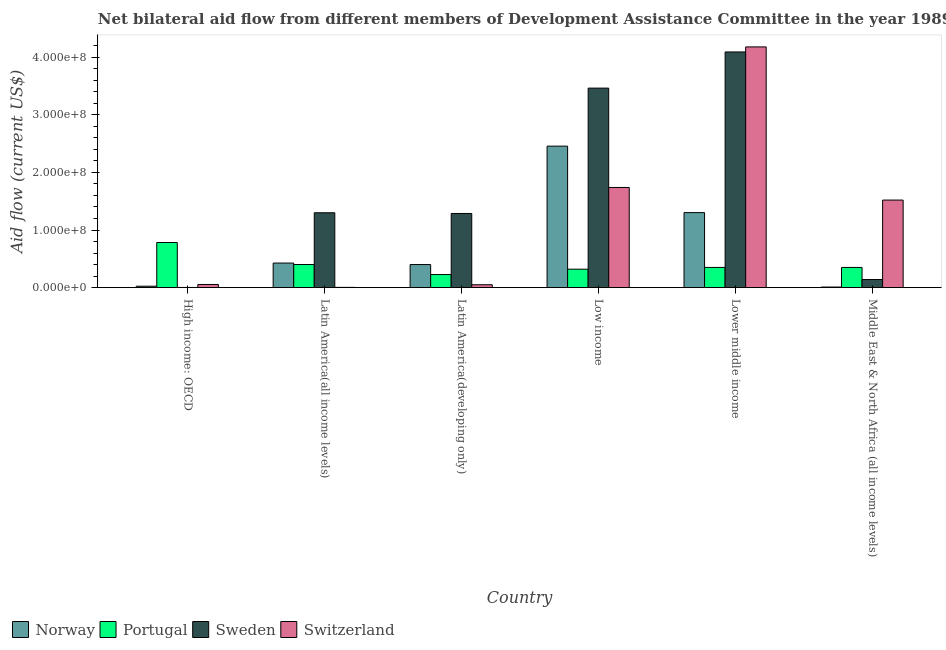How many different coloured bars are there?
Your response must be concise. 4. Are the number of bars on each tick of the X-axis equal?
Make the answer very short. Yes. How many bars are there on the 5th tick from the left?
Give a very brief answer. 4. What is the label of the 2nd group of bars from the left?
Provide a succinct answer. Latin America(all income levels). What is the amount of aid given by norway in Latin America(developing only)?
Ensure brevity in your answer.  4.01e+07. Across all countries, what is the maximum amount of aid given by portugal?
Your response must be concise. 7.84e+07. Across all countries, what is the minimum amount of aid given by switzerland?
Offer a terse response. 4.80e+05. In which country was the amount of aid given by switzerland maximum?
Your response must be concise. Lower middle income. In which country was the amount of aid given by portugal minimum?
Provide a short and direct response. Latin America(developing only). What is the total amount of aid given by portugal in the graph?
Your answer should be very brief. 2.44e+08. What is the difference between the amount of aid given by norway in High income: OECD and that in Latin America(developing only)?
Offer a terse response. -3.76e+07. What is the difference between the amount of aid given by switzerland in Latin America(developing only) and the amount of aid given by portugal in Middle East & North Africa (all income levels)?
Your answer should be compact. -3.00e+07. What is the average amount of aid given by switzerland per country?
Provide a short and direct response. 1.26e+08. What is the difference between the amount of aid given by sweden and amount of aid given by norway in Latin America(all income levels)?
Give a very brief answer. 8.72e+07. In how many countries, is the amount of aid given by portugal greater than 180000000 US$?
Your answer should be very brief. 0. What is the ratio of the amount of aid given by sweden in High income: OECD to that in Latin America(all income levels)?
Your answer should be compact. 0. Is the difference between the amount of aid given by portugal in Latin America(all income levels) and Middle East & North Africa (all income levels) greater than the difference between the amount of aid given by norway in Latin America(all income levels) and Middle East & North Africa (all income levels)?
Your answer should be very brief. No. What is the difference between the highest and the second highest amount of aid given by switzerland?
Provide a short and direct response. 2.44e+08. What is the difference between the highest and the lowest amount of aid given by switzerland?
Your answer should be compact. 4.17e+08. In how many countries, is the amount of aid given by switzerland greater than the average amount of aid given by switzerland taken over all countries?
Your answer should be compact. 3. Is it the case that in every country, the sum of the amount of aid given by portugal and amount of aid given by sweden is greater than the sum of amount of aid given by norway and amount of aid given by switzerland?
Keep it short and to the point. Yes. What does the 4th bar from the left in Low income represents?
Provide a short and direct response. Switzerland. What does the 1st bar from the right in Middle East & North Africa (all income levels) represents?
Your answer should be compact. Switzerland. Is it the case that in every country, the sum of the amount of aid given by norway and amount of aid given by portugal is greater than the amount of aid given by sweden?
Your answer should be compact. No. How many bars are there?
Your answer should be very brief. 24. Are the values on the major ticks of Y-axis written in scientific E-notation?
Ensure brevity in your answer.  Yes. Does the graph contain any zero values?
Offer a very short reply. No. Does the graph contain grids?
Keep it short and to the point. No. How many legend labels are there?
Make the answer very short. 4. How are the legend labels stacked?
Your answer should be compact. Horizontal. What is the title of the graph?
Offer a very short reply. Net bilateral aid flow from different members of Development Assistance Committee in the year 1989. Does "Portugal" appear as one of the legend labels in the graph?
Provide a short and direct response. Yes. What is the label or title of the X-axis?
Your answer should be very brief. Country. What is the Aid flow (current US$) of Norway in High income: OECD?
Your response must be concise. 2.52e+06. What is the Aid flow (current US$) of Portugal in High income: OECD?
Provide a succinct answer. 7.84e+07. What is the Aid flow (current US$) of Switzerland in High income: OECD?
Offer a terse response. 5.54e+06. What is the Aid flow (current US$) in Norway in Latin America(all income levels)?
Provide a short and direct response. 4.27e+07. What is the Aid flow (current US$) of Portugal in Latin America(all income levels)?
Offer a very short reply. 4.01e+07. What is the Aid flow (current US$) in Sweden in Latin America(all income levels)?
Your answer should be compact. 1.30e+08. What is the Aid flow (current US$) of Switzerland in Latin America(all income levels)?
Offer a terse response. 4.80e+05. What is the Aid flow (current US$) in Norway in Latin America(developing only)?
Provide a short and direct response. 4.01e+07. What is the Aid flow (current US$) in Portugal in Latin America(developing only)?
Your response must be concise. 2.28e+07. What is the Aid flow (current US$) of Sweden in Latin America(developing only)?
Your response must be concise. 1.29e+08. What is the Aid flow (current US$) in Switzerland in Latin America(developing only)?
Offer a terse response. 5.06e+06. What is the Aid flow (current US$) in Norway in Low income?
Your response must be concise. 2.45e+08. What is the Aid flow (current US$) in Portugal in Low income?
Your answer should be very brief. 3.21e+07. What is the Aid flow (current US$) of Sweden in Low income?
Give a very brief answer. 3.46e+08. What is the Aid flow (current US$) of Switzerland in Low income?
Keep it short and to the point. 1.74e+08. What is the Aid flow (current US$) of Norway in Lower middle income?
Your answer should be compact. 1.30e+08. What is the Aid flow (current US$) in Portugal in Lower middle income?
Provide a short and direct response. 3.51e+07. What is the Aid flow (current US$) in Sweden in Lower middle income?
Your response must be concise. 4.09e+08. What is the Aid flow (current US$) of Switzerland in Lower middle income?
Offer a very short reply. 4.18e+08. What is the Aid flow (current US$) in Norway in Middle East & North Africa (all income levels)?
Give a very brief answer. 1.06e+06. What is the Aid flow (current US$) of Portugal in Middle East & North Africa (all income levels)?
Provide a succinct answer. 3.51e+07. What is the Aid flow (current US$) in Sweden in Middle East & North Africa (all income levels)?
Ensure brevity in your answer.  1.41e+07. What is the Aid flow (current US$) of Switzerland in Middle East & North Africa (all income levels)?
Make the answer very short. 1.52e+08. Across all countries, what is the maximum Aid flow (current US$) of Norway?
Your response must be concise. 2.45e+08. Across all countries, what is the maximum Aid flow (current US$) in Portugal?
Provide a short and direct response. 7.84e+07. Across all countries, what is the maximum Aid flow (current US$) of Sweden?
Provide a succinct answer. 4.09e+08. Across all countries, what is the maximum Aid flow (current US$) of Switzerland?
Keep it short and to the point. 4.18e+08. Across all countries, what is the minimum Aid flow (current US$) in Norway?
Offer a very short reply. 1.06e+06. Across all countries, what is the minimum Aid flow (current US$) of Portugal?
Ensure brevity in your answer.  2.28e+07. Across all countries, what is the minimum Aid flow (current US$) in Sweden?
Offer a terse response. 3.60e+05. What is the total Aid flow (current US$) in Norway in the graph?
Your response must be concise. 4.62e+08. What is the total Aid flow (current US$) in Portugal in the graph?
Provide a succinct answer. 2.44e+08. What is the total Aid flow (current US$) in Sweden in the graph?
Keep it short and to the point. 1.03e+09. What is the total Aid flow (current US$) of Switzerland in the graph?
Keep it short and to the point. 7.54e+08. What is the difference between the Aid flow (current US$) in Norway in High income: OECD and that in Latin America(all income levels)?
Keep it short and to the point. -4.02e+07. What is the difference between the Aid flow (current US$) of Portugal in High income: OECD and that in Latin America(all income levels)?
Offer a very short reply. 3.82e+07. What is the difference between the Aid flow (current US$) in Sweden in High income: OECD and that in Latin America(all income levels)?
Your response must be concise. -1.30e+08. What is the difference between the Aid flow (current US$) of Switzerland in High income: OECD and that in Latin America(all income levels)?
Provide a short and direct response. 5.06e+06. What is the difference between the Aid flow (current US$) of Norway in High income: OECD and that in Latin America(developing only)?
Keep it short and to the point. -3.76e+07. What is the difference between the Aid flow (current US$) of Portugal in High income: OECD and that in Latin America(developing only)?
Provide a succinct answer. 5.56e+07. What is the difference between the Aid flow (current US$) of Sweden in High income: OECD and that in Latin America(developing only)?
Offer a very short reply. -1.28e+08. What is the difference between the Aid flow (current US$) in Switzerland in High income: OECD and that in Latin America(developing only)?
Offer a very short reply. 4.80e+05. What is the difference between the Aid flow (current US$) in Norway in High income: OECD and that in Low income?
Provide a succinct answer. -2.43e+08. What is the difference between the Aid flow (current US$) in Portugal in High income: OECD and that in Low income?
Your answer should be compact. 4.63e+07. What is the difference between the Aid flow (current US$) in Sweden in High income: OECD and that in Low income?
Make the answer very short. -3.46e+08. What is the difference between the Aid flow (current US$) in Switzerland in High income: OECD and that in Low income?
Make the answer very short. -1.68e+08. What is the difference between the Aid flow (current US$) of Norway in High income: OECD and that in Lower middle income?
Offer a very short reply. -1.28e+08. What is the difference between the Aid flow (current US$) of Portugal in High income: OECD and that in Lower middle income?
Your response must be concise. 4.33e+07. What is the difference between the Aid flow (current US$) of Sweden in High income: OECD and that in Lower middle income?
Provide a succinct answer. -4.09e+08. What is the difference between the Aid flow (current US$) in Switzerland in High income: OECD and that in Lower middle income?
Your answer should be very brief. -4.12e+08. What is the difference between the Aid flow (current US$) in Norway in High income: OECD and that in Middle East & North Africa (all income levels)?
Offer a very short reply. 1.46e+06. What is the difference between the Aid flow (current US$) in Portugal in High income: OECD and that in Middle East & North Africa (all income levels)?
Ensure brevity in your answer.  4.33e+07. What is the difference between the Aid flow (current US$) in Sweden in High income: OECD and that in Middle East & North Africa (all income levels)?
Give a very brief answer. -1.37e+07. What is the difference between the Aid flow (current US$) in Switzerland in High income: OECD and that in Middle East & North Africa (all income levels)?
Your answer should be compact. -1.46e+08. What is the difference between the Aid flow (current US$) in Norway in Latin America(all income levels) and that in Latin America(developing only)?
Ensure brevity in your answer.  2.59e+06. What is the difference between the Aid flow (current US$) in Portugal in Latin America(all income levels) and that in Latin America(developing only)?
Your answer should be very brief. 1.74e+07. What is the difference between the Aid flow (current US$) in Sweden in Latin America(all income levels) and that in Latin America(developing only)?
Offer a terse response. 1.23e+06. What is the difference between the Aid flow (current US$) in Switzerland in Latin America(all income levels) and that in Latin America(developing only)?
Make the answer very short. -4.58e+06. What is the difference between the Aid flow (current US$) in Norway in Latin America(all income levels) and that in Low income?
Ensure brevity in your answer.  -2.03e+08. What is the difference between the Aid flow (current US$) in Portugal in Latin America(all income levels) and that in Low income?
Keep it short and to the point. 8.08e+06. What is the difference between the Aid flow (current US$) of Sweden in Latin America(all income levels) and that in Low income?
Your response must be concise. -2.16e+08. What is the difference between the Aid flow (current US$) of Switzerland in Latin America(all income levels) and that in Low income?
Offer a very short reply. -1.73e+08. What is the difference between the Aid flow (current US$) in Norway in Latin America(all income levels) and that in Lower middle income?
Offer a very short reply. -8.75e+07. What is the difference between the Aid flow (current US$) of Portugal in Latin America(all income levels) and that in Lower middle income?
Your answer should be very brief. 5.04e+06. What is the difference between the Aid flow (current US$) in Sweden in Latin America(all income levels) and that in Lower middle income?
Your answer should be compact. -2.79e+08. What is the difference between the Aid flow (current US$) in Switzerland in Latin America(all income levels) and that in Lower middle income?
Give a very brief answer. -4.17e+08. What is the difference between the Aid flow (current US$) in Norway in Latin America(all income levels) and that in Middle East & North Africa (all income levels)?
Make the answer very short. 4.16e+07. What is the difference between the Aid flow (current US$) of Portugal in Latin America(all income levels) and that in Middle East & North Africa (all income levels)?
Provide a succinct answer. 5.04e+06. What is the difference between the Aid flow (current US$) of Sweden in Latin America(all income levels) and that in Middle East & North Africa (all income levels)?
Provide a succinct answer. 1.16e+08. What is the difference between the Aid flow (current US$) of Switzerland in Latin America(all income levels) and that in Middle East & North Africa (all income levels)?
Give a very brief answer. -1.51e+08. What is the difference between the Aid flow (current US$) in Norway in Latin America(developing only) and that in Low income?
Give a very brief answer. -2.05e+08. What is the difference between the Aid flow (current US$) in Portugal in Latin America(developing only) and that in Low income?
Your answer should be compact. -9.30e+06. What is the difference between the Aid flow (current US$) in Sweden in Latin America(developing only) and that in Low income?
Provide a short and direct response. -2.17e+08. What is the difference between the Aid flow (current US$) in Switzerland in Latin America(developing only) and that in Low income?
Your answer should be very brief. -1.69e+08. What is the difference between the Aid flow (current US$) in Norway in Latin America(developing only) and that in Lower middle income?
Keep it short and to the point. -9.01e+07. What is the difference between the Aid flow (current US$) of Portugal in Latin America(developing only) and that in Lower middle income?
Your answer should be compact. -1.23e+07. What is the difference between the Aid flow (current US$) in Sweden in Latin America(developing only) and that in Lower middle income?
Your answer should be compact. -2.80e+08. What is the difference between the Aid flow (current US$) in Switzerland in Latin America(developing only) and that in Lower middle income?
Your answer should be compact. -4.13e+08. What is the difference between the Aid flow (current US$) in Norway in Latin America(developing only) and that in Middle East & North Africa (all income levels)?
Ensure brevity in your answer.  3.90e+07. What is the difference between the Aid flow (current US$) of Portugal in Latin America(developing only) and that in Middle East & North Africa (all income levels)?
Offer a terse response. -1.23e+07. What is the difference between the Aid flow (current US$) of Sweden in Latin America(developing only) and that in Middle East & North Africa (all income levels)?
Offer a very short reply. 1.15e+08. What is the difference between the Aid flow (current US$) in Switzerland in Latin America(developing only) and that in Middle East & North Africa (all income levels)?
Ensure brevity in your answer.  -1.47e+08. What is the difference between the Aid flow (current US$) of Norway in Low income and that in Lower middle income?
Ensure brevity in your answer.  1.15e+08. What is the difference between the Aid flow (current US$) of Portugal in Low income and that in Lower middle income?
Give a very brief answer. -3.04e+06. What is the difference between the Aid flow (current US$) in Sweden in Low income and that in Lower middle income?
Give a very brief answer. -6.27e+07. What is the difference between the Aid flow (current US$) in Switzerland in Low income and that in Lower middle income?
Your response must be concise. -2.44e+08. What is the difference between the Aid flow (current US$) of Norway in Low income and that in Middle East & North Africa (all income levels)?
Keep it short and to the point. 2.44e+08. What is the difference between the Aid flow (current US$) in Portugal in Low income and that in Middle East & North Africa (all income levels)?
Your answer should be very brief. -3.04e+06. What is the difference between the Aid flow (current US$) in Sweden in Low income and that in Middle East & North Africa (all income levels)?
Provide a succinct answer. 3.32e+08. What is the difference between the Aid flow (current US$) of Switzerland in Low income and that in Middle East & North Africa (all income levels)?
Your answer should be compact. 2.18e+07. What is the difference between the Aid flow (current US$) in Norway in Lower middle income and that in Middle East & North Africa (all income levels)?
Offer a very short reply. 1.29e+08. What is the difference between the Aid flow (current US$) of Portugal in Lower middle income and that in Middle East & North Africa (all income levels)?
Make the answer very short. 0. What is the difference between the Aid flow (current US$) of Sweden in Lower middle income and that in Middle East & North Africa (all income levels)?
Make the answer very short. 3.95e+08. What is the difference between the Aid flow (current US$) in Switzerland in Lower middle income and that in Middle East & North Africa (all income levels)?
Offer a very short reply. 2.66e+08. What is the difference between the Aid flow (current US$) in Norway in High income: OECD and the Aid flow (current US$) in Portugal in Latin America(all income levels)?
Offer a terse response. -3.76e+07. What is the difference between the Aid flow (current US$) of Norway in High income: OECD and the Aid flow (current US$) of Sweden in Latin America(all income levels)?
Provide a succinct answer. -1.27e+08. What is the difference between the Aid flow (current US$) of Norway in High income: OECD and the Aid flow (current US$) of Switzerland in Latin America(all income levels)?
Keep it short and to the point. 2.04e+06. What is the difference between the Aid flow (current US$) of Portugal in High income: OECD and the Aid flow (current US$) of Sweden in Latin America(all income levels)?
Offer a very short reply. -5.16e+07. What is the difference between the Aid flow (current US$) in Portugal in High income: OECD and the Aid flow (current US$) in Switzerland in Latin America(all income levels)?
Give a very brief answer. 7.79e+07. What is the difference between the Aid flow (current US$) in Norway in High income: OECD and the Aid flow (current US$) in Portugal in Latin America(developing only)?
Make the answer very short. -2.02e+07. What is the difference between the Aid flow (current US$) in Norway in High income: OECD and the Aid flow (current US$) in Sweden in Latin America(developing only)?
Your answer should be compact. -1.26e+08. What is the difference between the Aid flow (current US$) of Norway in High income: OECD and the Aid flow (current US$) of Switzerland in Latin America(developing only)?
Keep it short and to the point. -2.54e+06. What is the difference between the Aid flow (current US$) in Portugal in High income: OECD and the Aid flow (current US$) in Sweden in Latin America(developing only)?
Provide a short and direct response. -5.03e+07. What is the difference between the Aid flow (current US$) of Portugal in High income: OECD and the Aid flow (current US$) of Switzerland in Latin America(developing only)?
Ensure brevity in your answer.  7.33e+07. What is the difference between the Aid flow (current US$) in Sweden in High income: OECD and the Aid flow (current US$) in Switzerland in Latin America(developing only)?
Your answer should be very brief. -4.70e+06. What is the difference between the Aid flow (current US$) of Norway in High income: OECD and the Aid flow (current US$) of Portugal in Low income?
Offer a terse response. -2.95e+07. What is the difference between the Aid flow (current US$) of Norway in High income: OECD and the Aid flow (current US$) of Sweden in Low income?
Your answer should be very brief. -3.44e+08. What is the difference between the Aid flow (current US$) in Norway in High income: OECD and the Aid flow (current US$) in Switzerland in Low income?
Offer a very short reply. -1.71e+08. What is the difference between the Aid flow (current US$) in Portugal in High income: OECD and the Aid flow (current US$) in Sweden in Low income?
Ensure brevity in your answer.  -2.68e+08. What is the difference between the Aid flow (current US$) in Portugal in High income: OECD and the Aid flow (current US$) in Switzerland in Low income?
Make the answer very short. -9.54e+07. What is the difference between the Aid flow (current US$) of Sweden in High income: OECD and the Aid flow (current US$) of Switzerland in Low income?
Keep it short and to the point. -1.73e+08. What is the difference between the Aid flow (current US$) of Norway in High income: OECD and the Aid flow (current US$) of Portugal in Lower middle income?
Give a very brief answer. -3.26e+07. What is the difference between the Aid flow (current US$) of Norway in High income: OECD and the Aid flow (current US$) of Sweden in Lower middle income?
Offer a very short reply. -4.06e+08. What is the difference between the Aid flow (current US$) of Norway in High income: OECD and the Aid flow (current US$) of Switzerland in Lower middle income?
Ensure brevity in your answer.  -4.15e+08. What is the difference between the Aid flow (current US$) in Portugal in High income: OECD and the Aid flow (current US$) in Sweden in Lower middle income?
Your answer should be compact. -3.31e+08. What is the difference between the Aid flow (current US$) in Portugal in High income: OECD and the Aid flow (current US$) in Switzerland in Lower middle income?
Keep it short and to the point. -3.39e+08. What is the difference between the Aid flow (current US$) of Sweden in High income: OECD and the Aid flow (current US$) of Switzerland in Lower middle income?
Make the answer very short. -4.17e+08. What is the difference between the Aid flow (current US$) in Norway in High income: OECD and the Aid flow (current US$) in Portugal in Middle East & North Africa (all income levels)?
Give a very brief answer. -3.26e+07. What is the difference between the Aid flow (current US$) of Norway in High income: OECD and the Aid flow (current US$) of Sweden in Middle East & North Africa (all income levels)?
Ensure brevity in your answer.  -1.16e+07. What is the difference between the Aid flow (current US$) in Norway in High income: OECD and the Aid flow (current US$) in Switzerland in Middle East & North Africa (all income levels)?
Give a very brief answer. -1.49e+08. What is the difference between the Aid flow (current US$) in Portugal in High income: OECD and the Aid flow (current US$) in Sweden in Middle East & North Africa (all income levels)?
Your answer should be compact. 6.43e+07. What is the difference between the Aid flow (current US$) in Portugal in High income: OECD and the Aid flow (current US$) in Switzerland in Middle East & North Africa (all income levels)?
Offer a terse response. -7.36e+07. What is the difference between the Aid flow (current US$) of Sweden in High income: OECD and the Aid flow (current US$) of Switzerland in Middle East & North Africa (all income levels)?
Provide a succinct answer. -1.52e+08. What is the difference between the Aid flow (current US$) of Norway in Latin America(all income levels) and the Aid flow (current US$) of Portugal in Latin America(developing only)?
Offer a terse response. 1.99e+07. What is the difference between the Aid flow (current US$) of Norway in Latin America(all income levels) and the Aid flow (current US$) of Sweden in Latin America(developing only)?
Offer a terse response. -8.60e+07. What is the difference between the Aid flow (current US$) of Norway in Latin America(all income levels) and the Aid flow (current US$) of Switzerland in Latin America(developing only)?
Your answer should be compact. 3.76e+07. What is the difference between the Aid flow (current US$) in Portugal in Latin America(all income levels) and the Aid flow (current US$) in Sweden in Latin America(developing only)?
Your answer should be very brief. -8.86e+07. What is the difference between the Aid flow (current US$) of Portugal in Latin America(all income levels) and the Aid flow (current US$) of Switzerland in Latin America(developing only)?
Offer a terse response. 3.51e+07. What is the difference between the Aid flow (current US$) in Sweden in Latin America(all income levels) and the Aid flow (current US$) in Switzerland in Latin America(developing only)?
Your answer should be compact. 1.25e+08. What is the difference between the Aid flow (current US$) in Norway in Latin America(all income levels) and the Aid flow (current US$) in Portugal in Low income?
Provide a short and direct response. 1.06e+07. What is the difference between the Aid flow (current US$) of Norway in Latin America(all income levels) and the Aid flow (current US$) of Sweden in Low income?
Your answer should be very brief. -3.03e+08. What is the difference between the Aid flow (current US$) of Norway in Latin America(all income levels) and the Aid flow (current US$) of Switzerland in Low income?
Offer a very short reply. -1.31e+08. What is the difference between the Aid flow (current US$) in Portugal in Latin America(all income levels) and the Aid flow (current US$) in Sweden in Low income?
Provide a succinct answer. -3.06e+08. What is the difference between the Aid flow (current US$) in Portugal in Latin America(all income levels) and the Aid flow (current US$) in Switzerland in Low income?
Ensure brevity in your answer.  -1.34e+08. What is the difference between the Aid flow (current US$) in Sweden in Latin America(all income levels) and the Aid flow (current US$) in Switzerland in Low income?
Make the answer very short. -4.39e+07. What is the difference between the Aid flow (current US$) of Norway in Latin America(all income levels) and the Aid flow (current US$) of Portugal in Lower middle income?
Provide a succinct answer. 7.59e+06. What is the difference between the Aid flow (current US$) of Norway in Latin America(all income levels) and the Aid flow (current US$) of Sweden in Lower middle income?
Your response must be concise. -3.66e+08. What is the difference between the Aid flow (current US$) in Norway in Latin America(all income levels) and the Aid flow (current US$) in Switzerland in Lower middle income?
Your answer should be compact. -3.75e+08. What is the difference between the Aid flow (current US$) in Portugal in Latin America(all income levels) and the Aid flow (current US$) in Sweden in Lower middle income?
Your response must be concise. -3.69e+08. What is the difference between the Aid flow (current US$) in Portugal in Latin America(all income levels) and the Aid flow (current US$) in Switzerland in Lower middle income?
Ensure brevity in your answer.  -3.78e+08. What is the difference between the Aid flow (current US$) of Sweden in Latin America(all income levels) and the Aid flow (current US$) of Switzerland in Lower middle income?
Your answer should be very brief. -2.88e+08. What is the difference between the Aid flow (current US$) of Norway in Latin America(all income levels) and the Aid flow (current US$) of Portugal in Middle East & North Africa (all income levels)?
Make the answer very short. 7.59e+06. What is the difference between the Aid flow (current US$) of Norway in Latin America(all income levels) and the Aid flow (current US$) of Sweden in Middle East & North Africa (all income levels)?
Ensure brevity in your answer.  2.86e+07. What is the difference between the Aid flow (current US$) of Norway in Latin America(all income levels) and the Aid flow (current US$) of Switzerland in Middle East & North Africa (all income levels)?
Provide a short and direct response. -1.09e+08. What is the difference between the Aid flow (current US$) in Portugal in Latin America(all income levels) and the Aid flow (current US$) in Sweden in Middle East & North Africa (all income levels)?
Keep it short and to the point. 2.60e+07. What is the difference between the Aid flow (current US$) in Portugal in Latin America(all income levels) and the Aid flow (current US$) in Switzerland in Middle East & North Africa (all income levels)?
Provide a succinct answer. -1.12e+08. What is the difference between the Aid flow (current US$) of Sweden in Latin America(all income levels) and the Aid flow (current US$) of Switzerland in Middle East & North Africa (all income levels)?
Make the answer very short. -2.20e+07. What is the difference between the Aid flow (current US$) of Norway in Latin America(developing only) and the Aid flow (current US$) of Portugal in Low income?
Provide a succinct answer. 8.04e+06. What is the difference between the Aid flow (current US$) in Norway in Latin America(developing only) and the Aid flow (current US$) in Sweden in Low income?
Your answer should be very brief. -3.06e+08. What is the difference between the Aid flow (current US$) of Norway in Latin America(developing only) and the Aid flow (current US$) of Switzerland in Low income?
Make the answer very short. -1.34e+08. What is the difference between the Aid flow (current US$) in Portugal in Latin America(developing only) and the Aid flow (current US$) in Sweden in Low income?
Your answer should be compact. -3.23e+08. What is the difference between the Aid flow (current US$) in Portugal in Latin America(developing only) and the Aid flow (current US$) in Switzerland in Low income?
Ensure brevity in your answer.  -1.51e+08. What is the difference between the Aid flow (current US$) of Sweden in Latin America(developing only) and the Aid flow (current US$) of Switzerland in Low income?
Your response must be concise. -4.51e+07. What is the difference between the Aid flow (current US$) in Norway in Latin America(developing only) and the Aid flow (current US$) in Portugal in Lower middle income?
Keep it short and to the point. 5.00e+06. What is the difference between the Aid flow (current US$) in Norway in Latin America(developing only) and the Aid flow (current US$) in Sweden in Lower middle income?
Offer a terse response. -3.69e+08. What is the difference between the Aid flow (current US$) in Norway in Latin America(developing only) and the Aid flow (current US$) in Switzerland in Lower middle income?
Keep it short and to the point. -3.78e+08. What is the difference between the Aid flow (current US$) of Portugal in Latin America(developing only) and the Aid flow (current US$) of Sweden in Lower middle income?
Give a very brief answer. -3.86e+08. What is the difference between the Aid flow (current US$) in Portugal in Latin America(developing only) and the Aid flow (current US$) in Switzerland in Lower middle income?
Provide a short and direct response. -3.95e+08. What is the difference between the Aid flow (current US$) in Sweden in Latin America(developing only) and the Aid flow (current US$) in Switzerland in Lower middle income?
Give a very brief answer. -2.89e+08. What is the difference between the Aid flow (current US$) in Norway in Latin America(developing only) and the Aid flow (current US$) in Sweden in Middle East & North Africa (all income levels)?
Make the answer very short. 2.60e+07. What is the difference between the Aid flow (current US$) of Norway in Latin America(developing only) and the Aid flow (current US$) of Switzerland in Middle East & North Africa (all income levels)?
Ensure brevity in your answer.  -1.12e+08. What is the difference between the Aid flow (current US$) of Portugal in Latin America(developing only) and the Aid flow (current US$) of Sweden in Middle East & North Africa (all income levels)?
Your response must be concise. 8.66e+06. What is the difference between the Aid flow (current US$) of Portugal in Latin America(developing only) and the Aid flow (current US$) of Switzerland in Middle East & North Africa (all income levels)?
Give a very brief answer. -1.29e+08. What is the difference between the Aid flow (current US$) of Sweden in Latin America(developing only) and the Aid flow (current US$) of Switzerland in Middle East & North Africa (all income levels)?
Keep it short and to the point. -2.33e+07. What is the difference between the Aid flow (current US$) in Norway in Low income and the Aid flow (current US$) in Portugal in Lower middle income?
Make the answer very short. 2.10e+08. What is the difference between the Aid flow (current US$) of Norway in Low income and the Aid flow (current US$) of Sweden in Lower middle income?
Provide a short and direct response. -1.63e+08. What is the difference between the Aid flow (current US$) of Norway in Low income and the Aid flow (current US$) of Switzerland in Lower middle income?
Offer a terse response. -1.72e+08. What is the difference between the Aid flow (current US$) of Portugal in Low income and the Aid flow (current US$) of Sweden in Lower middle income?
Give a very brief answer. -3.77e+08. What is the difference between the Aid flow (current US$) in Portugal in Low income and the Aid flow (current US$) in Switzerland in Lower middle income?
Ensure brevity in your answer.  -3.86e+08. What is the difference between the Aid flow (current US$) in Sweden in Low income and the Aid flow (current US$) in Switzerland in Lower middle income?
Your answer should be very brief. -7.15e+07. What is the difference between the Aid flow (current US$) of Norway in Low income and the Aid flow (current US$) of Portugal in Middle East & North Africa (all income levels)?
Provide a succinct answer. 2.10e+08. What is the difference between the Aid flow (current US$) in Norway in Low income and the Aid flow (current US$) in Sweden in Middle East & North Africa (all income levels)?
Keep it short and to the point. 2.31e+08. What is the difference between the Aid flow (current US$) of Norway in Low income and the Aid flow (current US$) of Switzerland in Middle East & North Africa (all income levels)?
Make the answer very short. 9.35e+07. What is the difference between the Aid flow (current US$) in Portugal in Low income and the Aid flow (current US$) in Sweden in Middle East & North Africa (all income levels)?
Your answer should be compact. 1.80e+07. What is the difference between the Aid flow (current US$) in Portugal in Low income and the Aid flow (current US$) in Switzerland in Middle East & North Africa (all income levels)?
Your answer should be very brief. -1.20e+08. What is the difference between the Aid flow (current US$) of Sweden in Low income and the Aid flow (current US$) of Switzerland in Middle East & North Africa (all income levels)?
Keep it short and to the point. 1.94e+08. What is the difference between the Aid flow (current US$) of Norway in Lower middle income and the Aid flow (current US$) of Portugal in Middle East & North Africa (all income levels)?
Make the answer very short. 9.51e+07. What is the difference between the Aid flow (current US$) of Norway in Lower middle income and the Aid flow (current US$) of Sweden in Middle East & North Africa (all income levels)?
Provide a short and direct response. 1.16e+08. What is the difference between the Aid flow (current US$) in Norway in Lower middle income and the Aid flow (current US$) in Switzerland in Middle East & North Africa (all income levels)?
Ensure brevity in your answer.  -2.18e+07. What is the difference between the Aid flow (current US$) in Portugal in Lower middle income and the Aid flow (current US$) in Sweden in Middle East & North Africa (all income levels)?
Your response must be concise. 2.10e+07. What is the difference between the Aid flow (current US$) in Portugal in Lower middle income and the Aid flow (current US$) in Switzerland in Middle East & North Africa (all income levels)?
Your answer should be compact. -1.17e+08. What is the difference between the Aid flow (current US$) of Sweden in Lower middle income and the Aid flow (current US$) of Switzerland in Middle East & North Africa (all income levels)?
Provide a short and direct response. 2.57e+08. What is the average Aid flow (current US$) in Norway per country?
Ensure brevity in your answer.  7.70e+07. What is the average Aid flow (current US$) of Portugal per country?
Your answer should be compact. 4.06e+07. What is the average Aid flow (current US$) in Sweden per country?
Provide a succinct answer. 1.71e+08. What is the average Aid flow (current US$) of Switzerland per country?
Make the answer very short. 1.26e+08. What is the difference between the Aid flow (current US$) of Norway and Aid flow (current US$) of Portugal in High income: OECD?
Ensure brevity in your answer.  -7.58e+07. What is the difference between the Aid flow (current US$) of Norway and Aid flow (current US$) of Sweden in High income: OECD?
Make the answer very short. 2.16e+06. What is the difference between the Aid flow (current US$) in Norway and Aid flow (current US$) in Switzerland in High income: OECD?
Your response must be concise. -3.02e+06. What is the difference between the Aid flow (current US$) of Portugal and Aid flow (current US$) of Sweden in High income: OECD?
Your answer should be very brief. 7.80e+07. What is the difference between the Aid flow (current US$) of Portugal and Aid flow (current US$) of Switzerland in High income: OECD?
Ensure brevity in your answer.  7.28e+07. What is the difference between the Aid flow (current US$) in Sweden and Aid flow (current US$) in Switzerland in High income: OECD?
Offer a terse response. -5.18e+06. What is the difference between the Aid flow (current US$) of Norway and Aid flow (current US$) of Portugal in Latin America(all income levels)?
Make the answer very short. 2.55e+06. What is the difference between the Aid flow (current US$) in Norway and Aid flow (current US$) in Sweden in Latin America(all income levels)?
Your answer should be compact. -8.72e+07. What is the difference between the Aid flow (current US$) in Norway and Aid flow (current US$) in Switzerland in Latin America(all income levels)?
Provide a short and direct response. 4.22e+07. What is the difference between the Aid flow (current US$) in Portugal and Aid flow (current US$) in Sweden in Latin America(all income levels)?
Provide a short and direct response. -8.98e+07. What is the difference between the Aid flow (current US$) of Portugal and Aid flow (current US$) of Switzerland in Latin America(all income levels)?
Offer a terse response. 3.97e+07. What is the difference between the Aid flow (current US$) of Sweden and Aid flow (current US$) of Switzerland in Latin America(all income levels)?
Your answer should be very brief. 1.29e+08. What is the difference between the Aid flow (current US$) in Norway and Aid flow (current US$) in Portugal in Latin America(developing only)?
Provide a short and direct response. 1.73e+07. What is the difference between the Aid flow (current US$) in Norway and Aid flow (current US$) in Sweden in Latin America(developing only)?
Give a very brief answer. -8.86e+07. What is the difference between the Aid flow (current US$) in Norway and Aid flow (current US$) in Switzerland in Latin America(developing only)?
Your response must be concise. 3.50e+07. What is the difference between the Aid flow (current US$) of Portugal and Aid flow (current US$) of Sweden in Latin America(developing only)?
Provide a succinct answer. -1.06e+08. What is the difference between the Aid flow (current US$) in Portugal and Aid flow (current US$) in Switzerland in Latin America(developing only)?
Your response must be concise. 1.77e+07. What is the difference between the Aid flow (current US$) in Sweden and Aid flow (current US$) in Switzerland in Latin America(developing only)?
Keep it short and to the point. 1.24e+08. What is the difference between the Aid flow (current US$) in Norway and Aid flow (current US$) in Portugal in Low income?
Ensure brevity in your answer.  2.13e+08. What is the difference between the Aid flow (current US$) of Norway and Aid flow (current US$) of Sweden in Low income?
Offer a very short reply. -1.01e+08. What is the difference between the Aid flow (current US$) of Norway and Aid flow (current US$) of Switzerland in Low income?
Provide a succinct answer. 7.17e+07. What is the difference between the Aid flow (current US$) in Portugal and Aid flow (current US$) in Sweden in Low income?
Give a very brief answer. -3.14e+08. What is the difference between the Aid flow (current US$) in Portugal and Aid flow (current US$) in Switzerland in Low income?
Keep it short and to the point. -1.42e+08. What is the difference between the Aid flow (current US$) in Sweden and Aid flow (current US$) in Switzerland in Low income?
Your answer should be very brief. 1.72e+08. What is the difference between the Aid flow (current US$) of Norway and Aid flow (current US$) of Portugal in Lower middle income?
Provide a succinct answer. 9.51e+07. What is the difference between the Aid flow (current US$) of Norway and Aid flow (current US$) of Sweden in Lower middle income?
Your response must be concise. -2.79e+08. What is the difference between the Aid flow (current US$) in Norway and Aid flow (current US$) in Switzerland in Lower middle income?
Ensure brevity in your answer.  -2.87e+08. What is the difference between the Aid flow (current US$) of Portugal and Aid flow (current US$) of Sweden in Lower middle income?
Offer a terse response. -3.74e+08. What is the difference between the Aid flow (current US$) in Portugal and Aid flow (current US$) in Switzerland in Lower middle income?
Keep it short and to the point. -3.83e+08. What is the difference between the Aid flow (current US$) of Sweden and Aid flow (current US$) of Switzerland in Lower middle income?
Provide a succinct answer. -8.76e+06. What is the difference between the Aid flow (current US$) of Norway and Aid flow (current US$) of Portugal in Middle East & North Africa (all income levels)?
Your answer should be very brief. -3.40e+07. What is the difference between the Aid flow (current US$) in Norway and Aid flow (current US$) in Sweden in Middle East & North Africa (all income levels)?
Provide a short and direct response. -1.30e+07. What is the difference between the Aid flow (current US$) of Norway and Aid flow (current US$) of Switzerland in Middle East & North Africa (all income levels)?
Ensure brevity in your answer.  -1.51e+08. What is the difference between the Aid flow (current US$) of Portugal and Aid flow (current US$) of Sweden in Middle East & North Africa (all income levels)?
Make the answer very short. 2.10e+07. What is the difference between the Aid flow (current US$) in Portugal and Aid flow (current US$) in Switzerland in Middle East & North Africa (all income levels)?
Give a very brief answer. -1.17e+08. What is the difference between the Aid flow (current US$) of Sweden and Aid flow (current US$) of Switzerland in Middle East & North Africa (all income levels)?
Your answer should be very brief. -1.38e+08. What is the ratio of the Aid flow (current US$) in Norway in High income: OECD to that in Latin America(all income levels)?
Ensure brevity in your answer.  0.06. What is the ratio of the Aid flow (current US$) in Portugal in High income: OECD to that in Latin America(all income levels)?
Your response must be concise. 1.95. What is the ratio of the Aid flow (current US$) of Sweden in High income: OECD to that in Latin America(all income levels)?
Your response must be concise. 0. What is the ratio of the Aid flow (current US$) of Switzerland in High income: OECD to that in Latin America(all income levels)?
Your answer should be very brief. 11.54. What is the ratio of the Aid flow (current US$) in Norway in High income: OECD to that in Latin America(developing only)?
Provide a short and direct response. 0.06. What is the ratio of the Aid flow (current US$) of Portugal in High income: OECD to that in Latin America(developing only)?
Provide a short and direct response. 3.44. What is the ratio of the Aid flow (current US$) in Sweden in High income: OECD to that in Latin America(developing only)?
Your answer should be compact. 0. What is the ratio of the Aid flow (current US$) of Switzerland in High income: OECD to that in Latin America(developing only)?
Give a very brief answer. 1.09. What is the ratio of the Aid flow (current US$) in Norway in High income: OECD to that in Low income?
Your answer should be compact. 0.01. What is the ratio of the Aid flow (current US$) in Portugal in High income: OECD to that in Low income?
Make the answer very short. 2.44. What is the ratio of the Aid flow (current US$) of Sweden in High income: OECD to that in Low income?
Your answer should be very brief. 0. What is the ratio of the Aid flow (current US$) in Switzerland in High income: OECD to that in Low income?
Give a very brief answer. 0.03. What is the ratio of the Aid flow (current US$) in Norway in High income: OECD to that in Lower middle income?
Your answer should be very brief. 0.02. What is the ratio of the Aid flow (current US$) in Portugal in High income: OECD to that in Lower middle income?
Make the answer very short. 2.23. What is the ratio of the Aid flow (current US$) in Sweden in High income: OECD to that in Lower middle income?
Give a very brief answer. 0. What is the ratio of the Aid flow (current US$) in Switzerland in High income: OECD to that in Lower middle income?
Make the answer very short. 0.01. What is the ratio of the Aid flow (current US$) in Norway in High income: OECD to that in Middle East & North Africa (all income levels)?
Offer a terse response. 2.38. What is the ratio of the Aid flow (current US$) in Portugal in High income: OECD to that in Middle East & North Africa (all income levels)?
Give a very brief answer. 2.23. What is the ratio of the Aid flow (current US$) of Sweden in High income: OECD to that in Middle East & North Africa (all income levels)?
Offer a terse response. 0.03. What is the ratio of the Aid flow (current US$) in Switzerland in High income: OECD to that in Middle East & North Africa (all income levels)?
Your answer should be compact. 0.04. What is the ratio of the Aid flow (current US$) in Norway in Latin America(all income levels) to that in Latin America(developing only)?
Offer a very short reply. 1.06. What is the ratio of the Aid flow (current US$) of Portugal in Latin America(all income levels) to that in Latin America(developing only)?
Your answer should be very brief. 1.76. What is the ratio of the Aid flow (current US$) in Sweden in Latin America(all income levels) to that in Latin America(developing only)?
Give a very brief answer. 1.01. What is the ratio of the Aid flow (current US$) of Switzerland in Latin America(all income levels) to that in Latin America(developing only)?
Your answer should be very brief. 0.09. What is the ratio of the Aid flow (current US$) in Norway in Latin America(all income levels) to that in Low income?
Offer a very short reply. 0.17. What is the ratio of the Aid flow (current US$) in Portugal in Latin America(all income levels) to that in Low income?
Offer a very short reply. 1.25. What is the ratio of the Aid flow (current US$) of Sweden in Latin America(all income levels) to that in Low income?
Your answer should be very brief. 0.38. What is the ratio of the Aid flow (current US$) of Switzerland in Latin America(all income levels) to that in Low income?
Keep it short and to the point. 0. What is the ratio of the Aid flow (current US$) of Norway in Latin America(all income levels) to that in Lower middle income?
Keep it short and to the point. 0.33. What is the ratio of the Aid flow (current US$) of Portugal in Latin America(all income levels) to that in Lower middle income?
Offer a terse response. 1.14. What is the ratio of the Aid flow (current US$) of Sweden in Latin America(all income levels) to that in Lower middle income?
Your answer should be compact. 0.32. What is the ratio of the Aid flow (current US$) in Switzerland in Latin America(all income levels) to that in Lower middle income?
Your answer should be very brief. 0. What is the ratio of the Aid flow (current US$) in Norway in Latin America(all income levels) to that in Middle East & North Africa (all income levels)?
Offer a terse response. 40.27. What is the ratio of the Aid flow (current US$) of Portugal in Latin America(all income levels) to that in Middle East & North Africa (all income levels)?
Keep it short and to the point. 1.14. What is the ratio of the Aid flow (current US$) in Sweden in Latin America(all income levels) to that in Middle East & North Africa (all income levels)?
Your answer should be very brief. 9.21. What is the ratio of the Aid flow (current US$) of Switzerland in Latin America(all income levels) to that in Middle East & North Africa (all income levels)?
Your response must be concise. 0. What is the ratio of the Aid flow (current US$) of Norway in Latin America(developing only) to that in Low income?
Provide a short and direct response. 0.16. What is the ratio of the Aid flow (current US$) in Portugal in Latin America(developing only) to that in Low income?
Your answer should be very brief. 0.71. What is the ratio of the Aid flow (current US$) in Sweden in Latin America(developing only) to that in Low income?
Ensure brevity in your answer.  0.37. What is the ratio of the Aid flow (current US$) in Switzerland in Latin America(developing only) to that in Low income?
Provide a succinct answer. 0.03. What is the ratio of the Aid flow (current US$) in Norway in Latin America(developing only) to that in Lower middle income?
Ensure brevity in your answer.  0.31. What is the ratio of the Aid flow (current US$) of Portugal in Latin America(developing only) to that in Lower middle income?
Offer a very short reply. 0.65. What is the ratio of the Aid flow (current US$) in Sweden in Latin America(developing only) to that in Lower middle income?
Keep it short and to the point. 0.31. What is the ratio of the Aid flow (current US$) of Switzerland in Latin America(developing only) to that in Lower middle income?
Make the answer very short. 0.01. What is the ratio of the Aid flow (current US$) of Norway in Latin America(developing only) to that in Middle East & North Africa (all income levels)?
Your answer should be very brief. 37.83. What is the ratio of the Aid flow (current US$) of Portugal in Latin America(developing only) to that in Middle East & North Africa (all income levels)?
Offer a terse response. 0.65. What is the ratio of the Aid flow (current US$) of Sweden in Latin America(developing only) to that in Middle East & North Africa (all income levels)?
Make the answer very short. 9.13. What is the ratio of the Aid flow (current US$) of Norway in Low income to that in Lower middle income?
Give a very brief answer. 1.89. What is the ratio of the Aid flow (current US$) in Portugal in Low income to that in Lower middle income?
Give a very brief answer. 0.91. What is the ratio of the Aid flow (current US$) of Sweden in Low income to that in Lower middle income?
Offer a terse response. 0.85. What is the ratio of the Aid flow (current US$) of Switzerland in Low income to that in Lower middle income?
Your response must be concise. 0.42. What is the ratio of the Aid flow (current US$) in Norway in Low income to that in Middle East & North Africa (all income levels)?
Give a very brief answer. 231.59. What is the ratio of the Aid flow (current US$) in Portugal in Low income to that in Middle East & North Africa (all income levels)?
Your answer should be very brief. 0.91. What is the ratio of the Aid flow (current US$) of Sweden in Low income to that in Middle East & North Africa (all income levels)?
Your answer should be compact. 24.55. What is the ratio of the Aid flow (current US$) of Switzerland in Low income to that in Middle East & North Africa (all income levels)?
Your response must be concise. 1.14. What is the ratio of the Aid flow (current US$) of Norway in Lower middle income to that in Middle East & North Africa (all income levels)?
Make the answer very short. 122.81. What is the ratio of the Aid flow (current US$) of Portugal in Lower middle income to that in Middle East & North Africa (all income levels)?
Make the answer very short. 1. What is the ratio of the Aid flow (current US$) of Sweden in Lower middle income to that in Middle East & North Africa (all income levels)?
Your answer should be very brief. 29. What is the ratio of the Aid flow (current US$) of Switzerland in Lower middle income to that in Middle East & North Africa (all income levels)?
Your response must be concise. 2.75. What is the difference between the highest and the second highest Aid flow (current US$) of Norway?
Provide a short and direct response. 1.15e+08. What is the difference between the highest and the second highest Aid flow (current US$) in Portugal?
Your response must be concise. 3.82e+07. What is the difference between the highest and the second highest Aid flow (current US$) of Sweden?
Make the answer very short. 6.27e+07. What is the difference between the highest and the second highest Aid flow (current US$) in Switzerland?
Make the answer very short. 2.44e+08. What is the difference between the highest and the lowest Aid flow (current US$) in Norway?
Give a very brief answer. 2.44e+08. What is the difference between the highest and the lowest Aid flow (current US$) in Portugal?
Your answer should be very brief. 5.56e+07. What is the difference between the highest and the lowest Aid flow (current US$) of Sweden?
Offer a very short reply. 4.09e+08. What is the difference between the highest and the lowest Aid flow (current US$) in Switzerland?
Provide a short and direct response. 4.17e+08. 